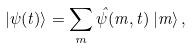<formula> <loc_0><loc_0><loc_500><loc_500>| \psi ( t ) \rangle = \sum _ { m } \hat { \psi } ( m , t ) \, | m \rangle \, ,</formula> 